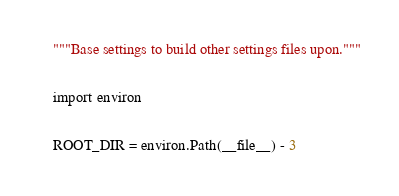<code> <loc_0><loc_0><loc_500><loc_500><_Python_>"""Base settings to build other settings files upon."""

import environ

ROOT_DIR = environ.Path(__file__) - 3</code> 